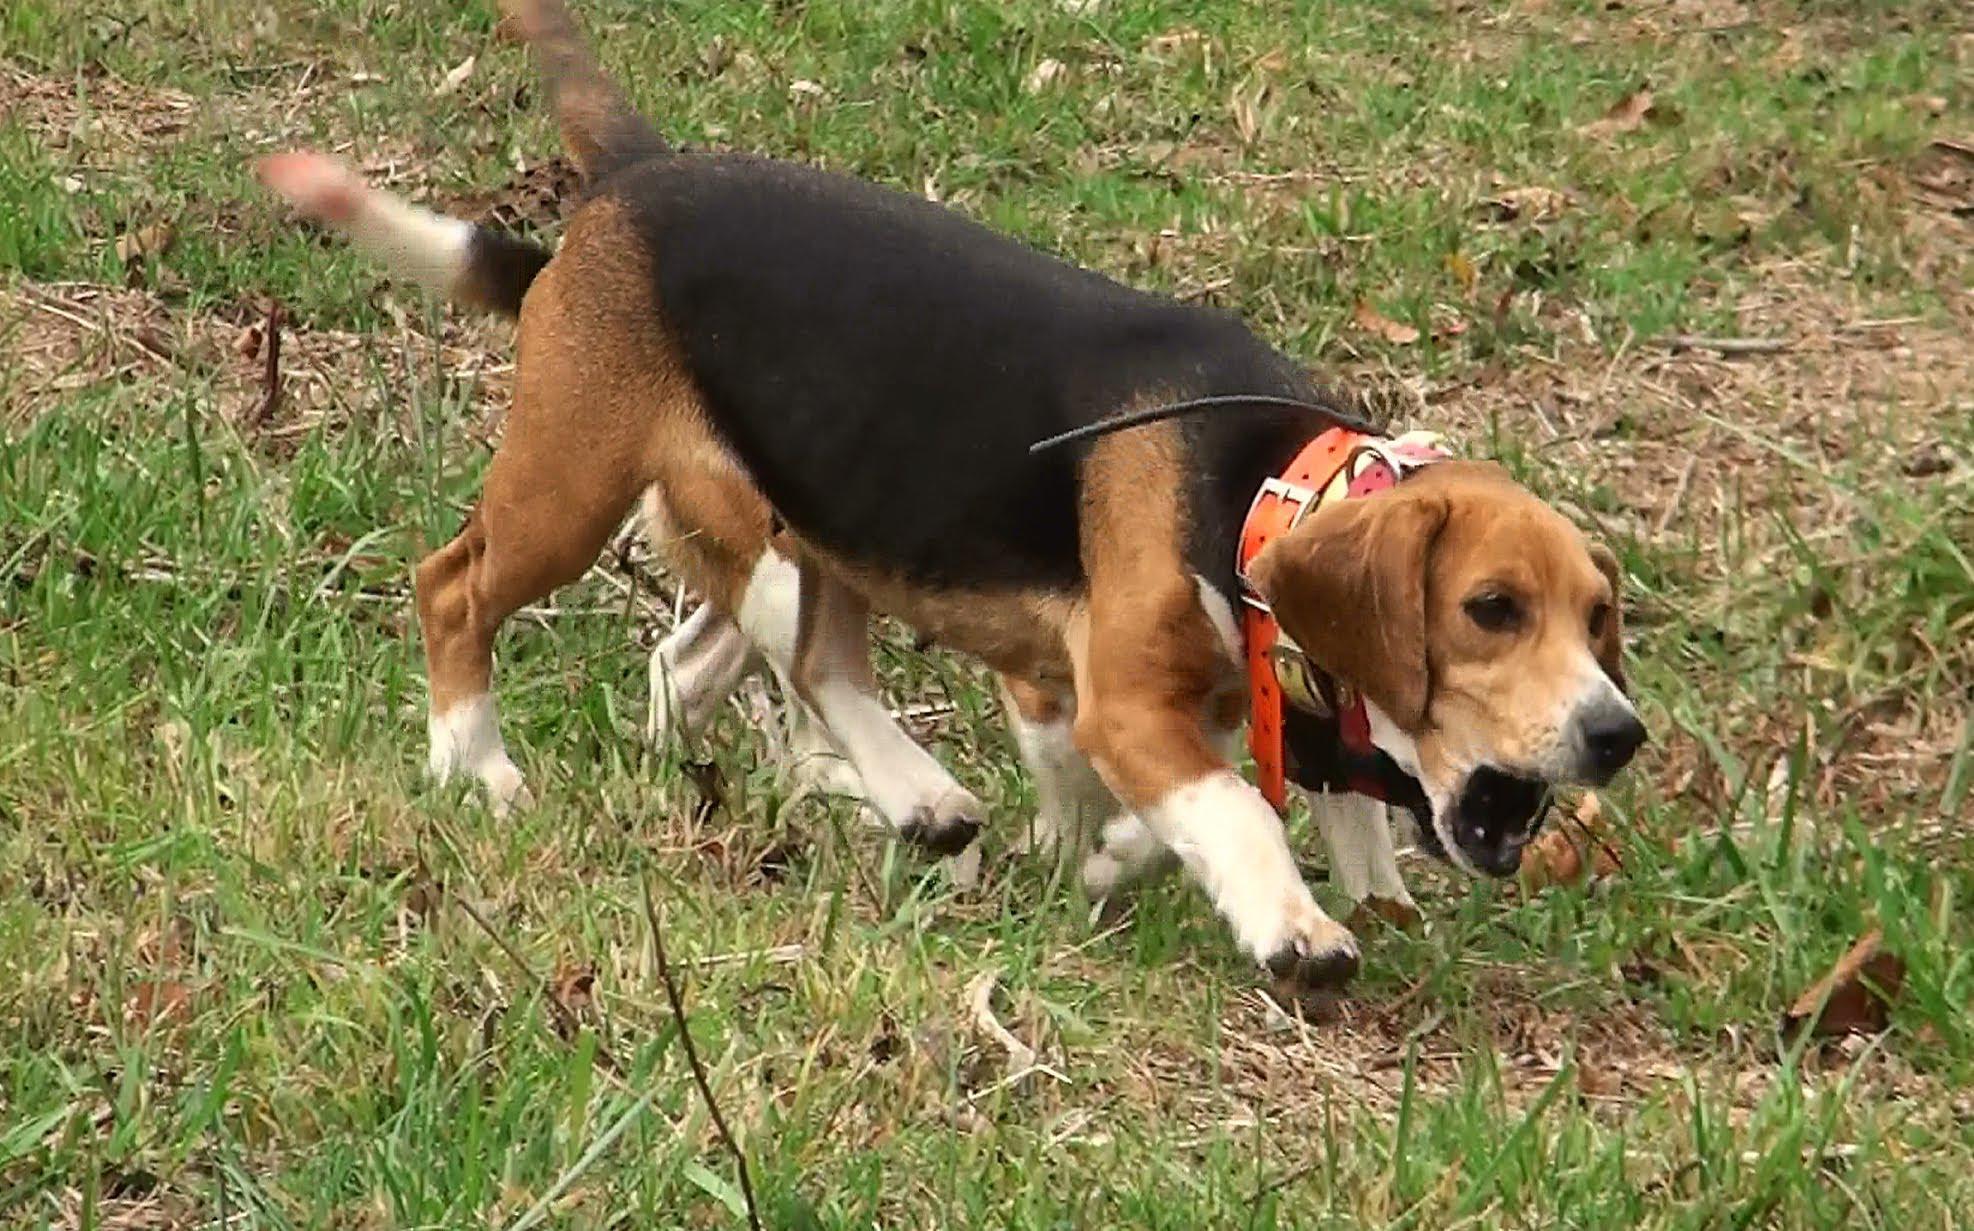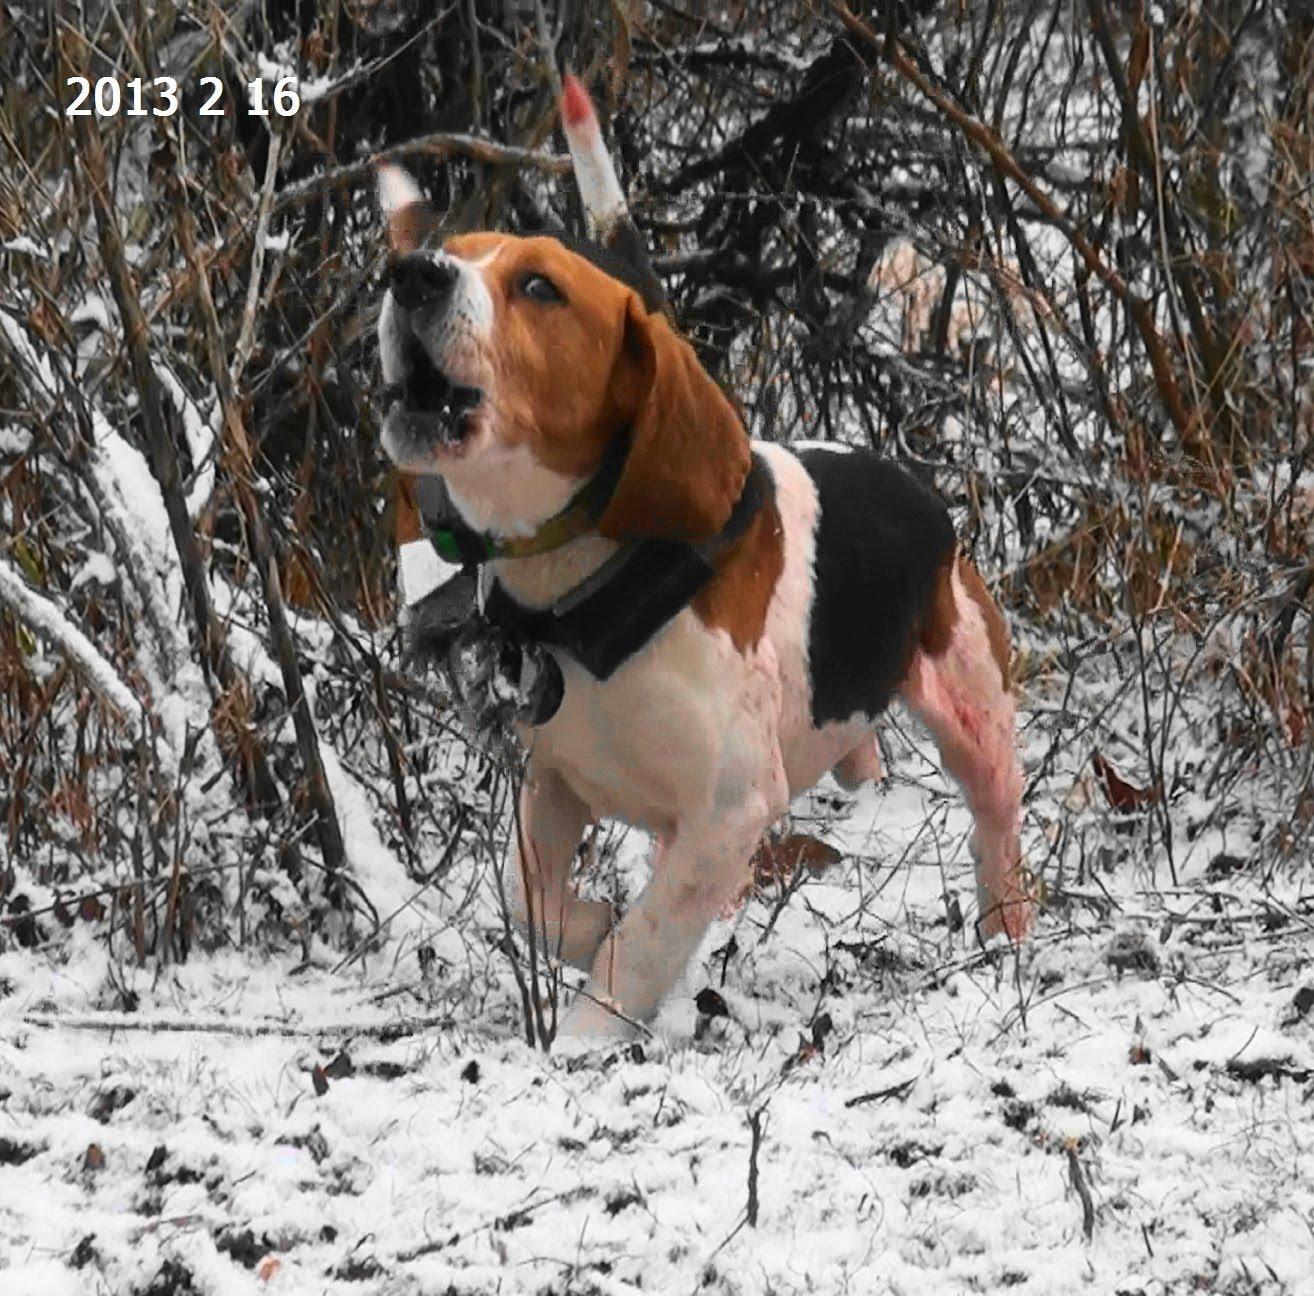The first image is the image on the left, the second image is the image on the right. For the images displayed, is the sentence "in at least one photo a man is using a walking stick on the grass" factually correct? Answer yes or no. No. The first image is the image on the left, the second image is the image on the right. Considering the images on both sides, is "One image has no more than one dog." valid? Answer yes or no. Yes. 